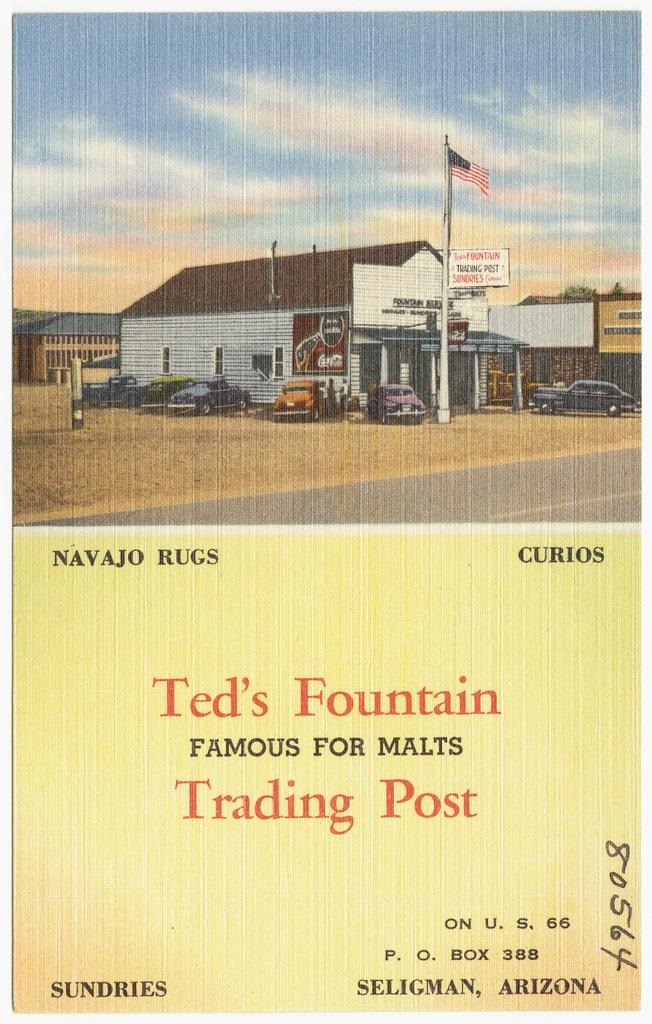What type of visual representation is the image? The image is a poster. What can be seen in the poster besides the poster itself? There are vehicles, a building, a pole, a flag, and a banner in the poster. What is the weather like in the poster? There are clouds in the poster, and the sky is visible, suggesting a partly cloudy day. What knowledge does the dad share with the fan in the poster? There is no dad or fan present in the poster; it features vehicles, a building, a pole, a flag, and a banner. 